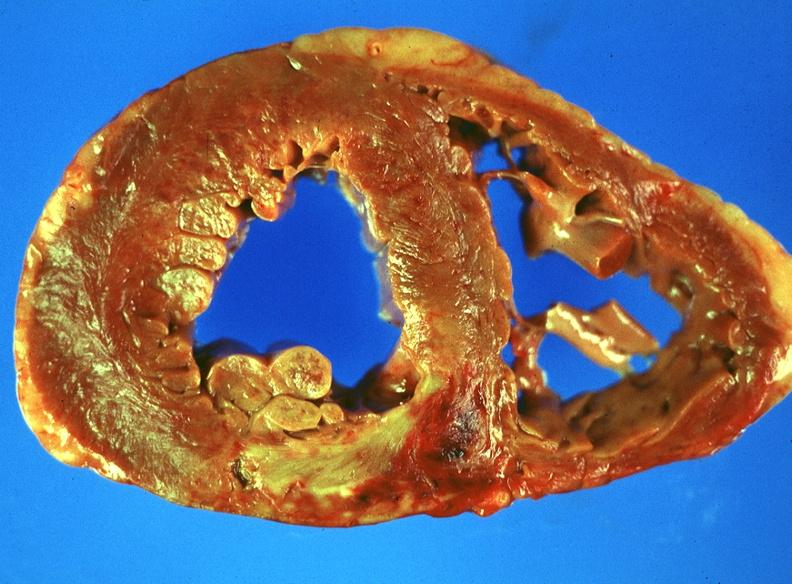what is present?
Answer the question using a single word or phrase. Cardiovascular 